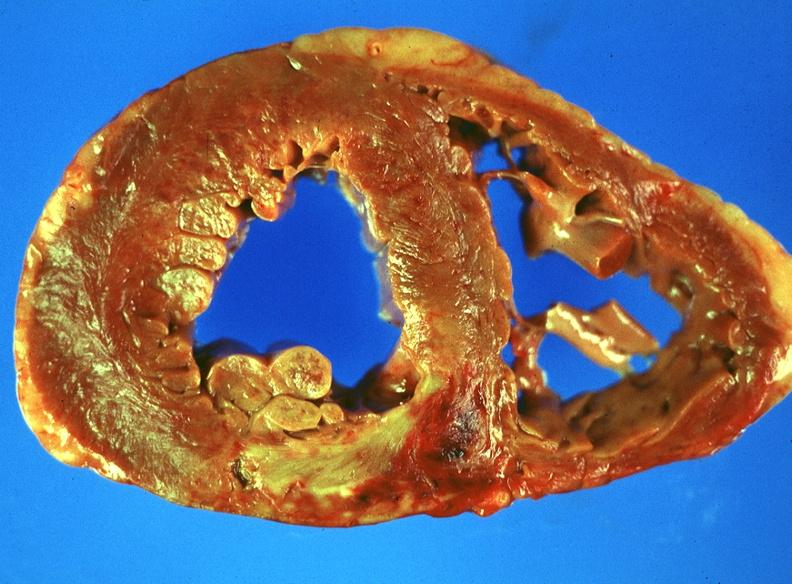what is present?
Answer the question using a single word or phrase. Cardiovascular 